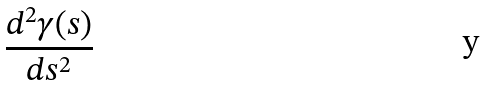<formula> <loc_0><loc_0><loc_500><loc_500>\frac { d ^ { 2 } \gamma ( s ) } { d s ^ { 2 } }</formula> 